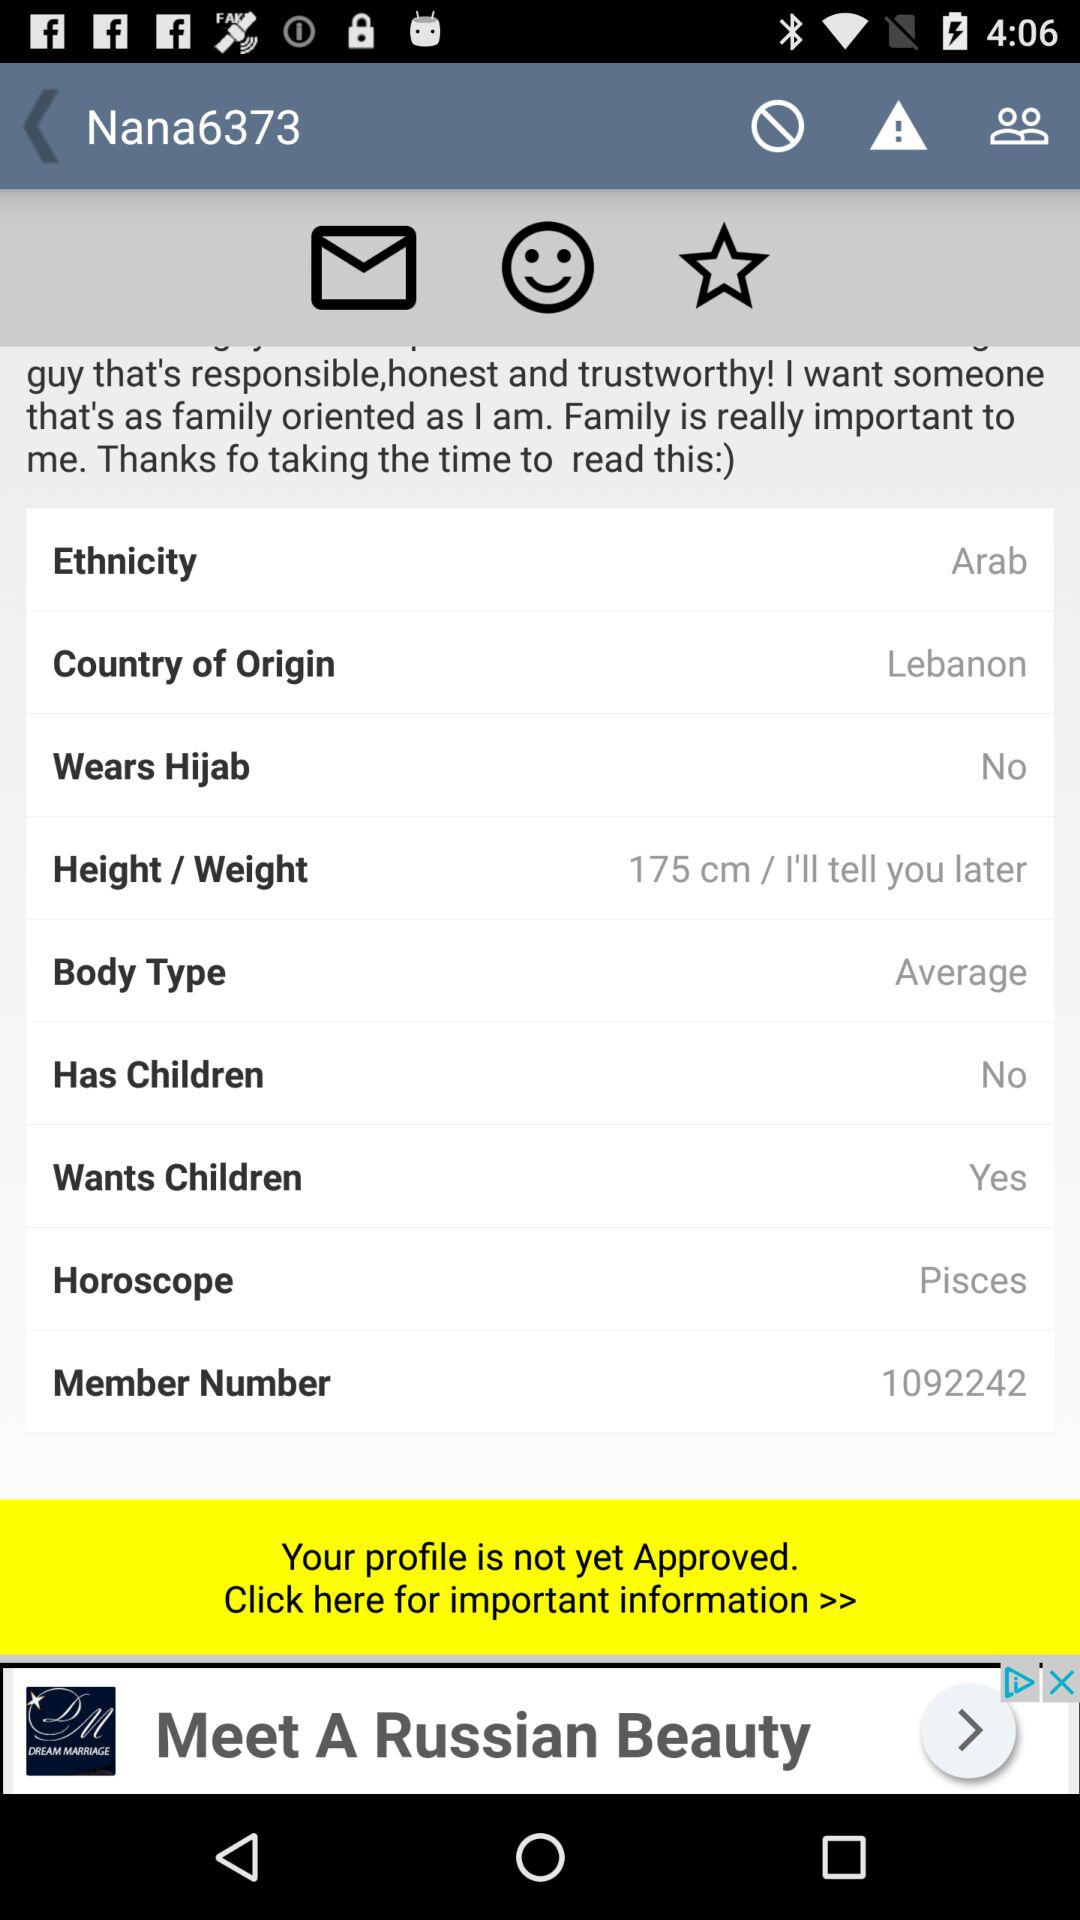What is the ethnicity of the person? The ethnicity of the person is Arab. 